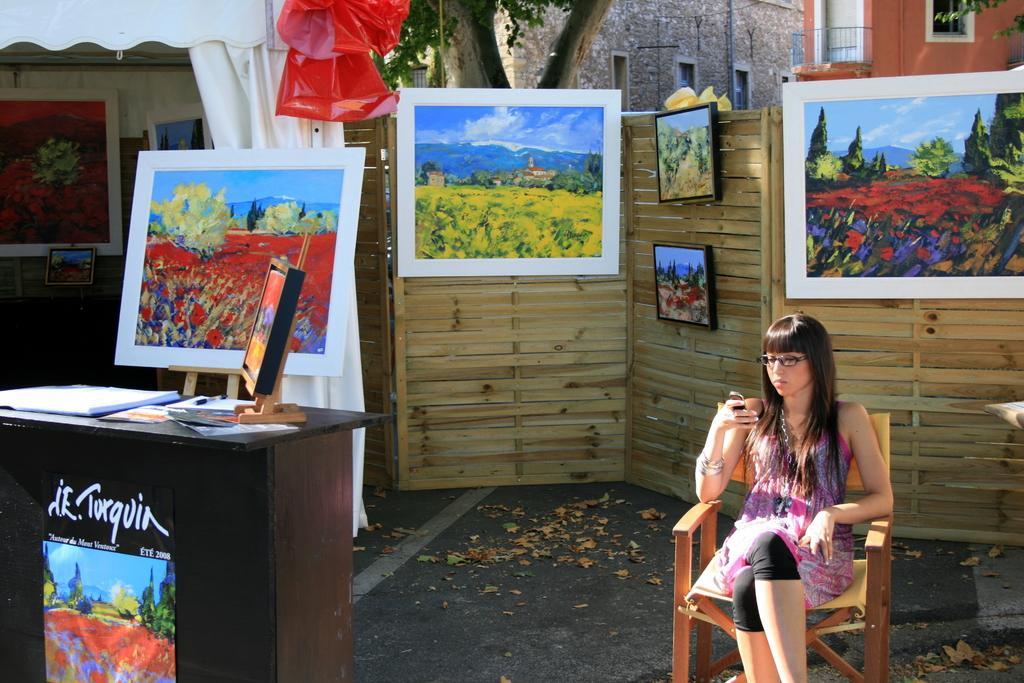Could you give a brief overview of what you see in this image? In the foreground of this image, there is a woman sitting on the chair and in the background, there are frames to the wooden wall, curtain, building,tree, and a window. On left, there is a table on which a frame stand and papers are placed on it. 